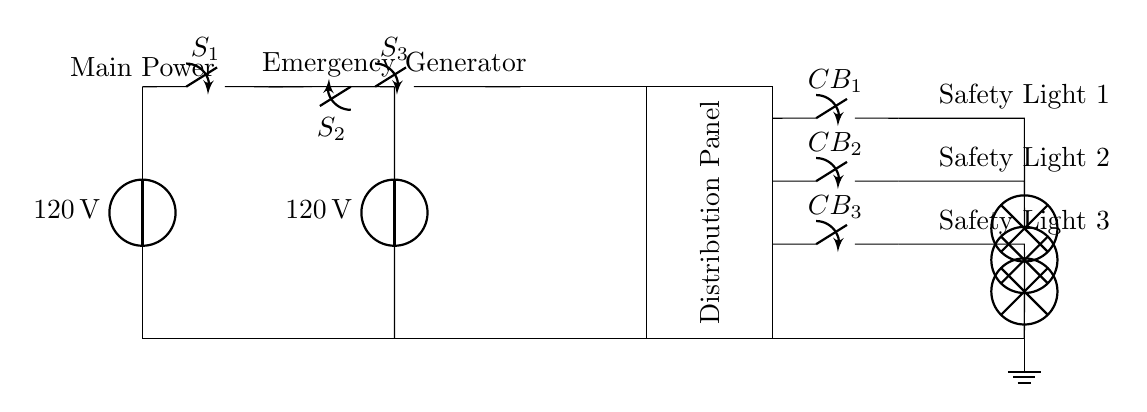What is the primary voltage source in this circuit? The primary voltage source is located at the left side of the diagram and is labeled as 120 volts.
Answer: 120 volts What is the role of switch S1? Switch S1 connects the main power supply to the circuit, allowing the main power to be used for the safety lighting when it is closed.
Answer: Connects main power How many safety lights are there in this circuit? The circuit diagram displays three distinct safety lights connected to the distribution panel.
Answer: Three What does the transfer switch S3 do? The transfer switch S3 allows for the selection between the main power supply and the emergency generator, facilitating a smooth transition if one power source is lost.
Answer: Selects power source Which component provides backup power in case of main power failure? The emergency generator provides backup power when the main power fails, ensuring that the safety lights remain operational.
Answer: Emergency generator 